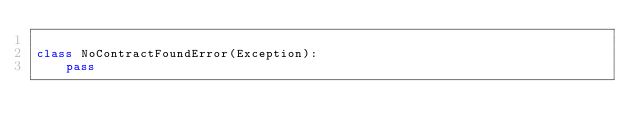Convert code to text. <code><loc_0><loc_0><loc_500><loc_500><_Python_>
class NoContractFoundError(Exception):
    pass</code> 